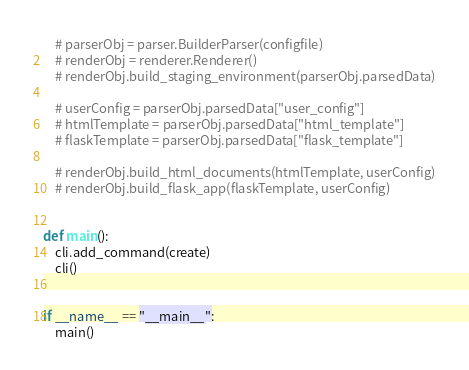<code> <loc_0><loc_0><loc_500><loc_500><_Python_>    # parserObj = parser.BuilderParser(configfile)
    # renderObj = renderer.Renderer()
    # renderObj.build_staging_environment(parserObj.parsedData)

    # userConfig = parserObj.parsedData["user_config"]
    # htmlTemplate = parserObj.parsedData["html_template"]
    # flaskTemplate = parserObj.parsedData["flask_template"]

    # renderObj.build_html_documents(htmlTemplate, userConfig)
    # renderObj.build_flask_app(flaskTemplate, userConfig)


def main():
    cli.add_command(create)
    cli()


if __name__ == "__main__":
    main()
</code> 